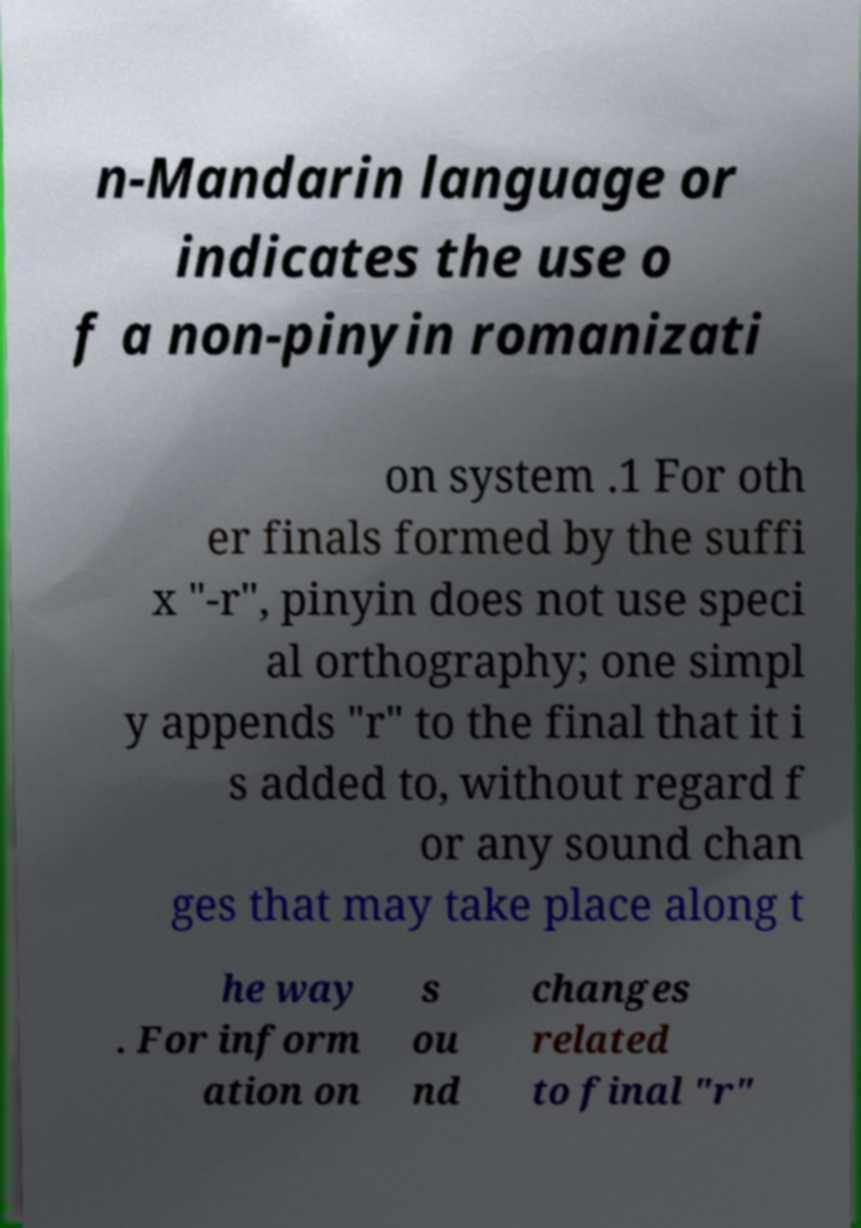Please read and relay the text visible in this image. What does it say? n-Mandarin language or indicates the use o f a non-pinyin romanizati on system .1 For oth er finals formed by the suffi x "-r", pinyin does not use speci al orthography; one simpl y appends "r" to the final that it i s added to, without regard f or any sound chan ges that may take place along t he way . For inform ation on s ou nd changes related to final "r" 